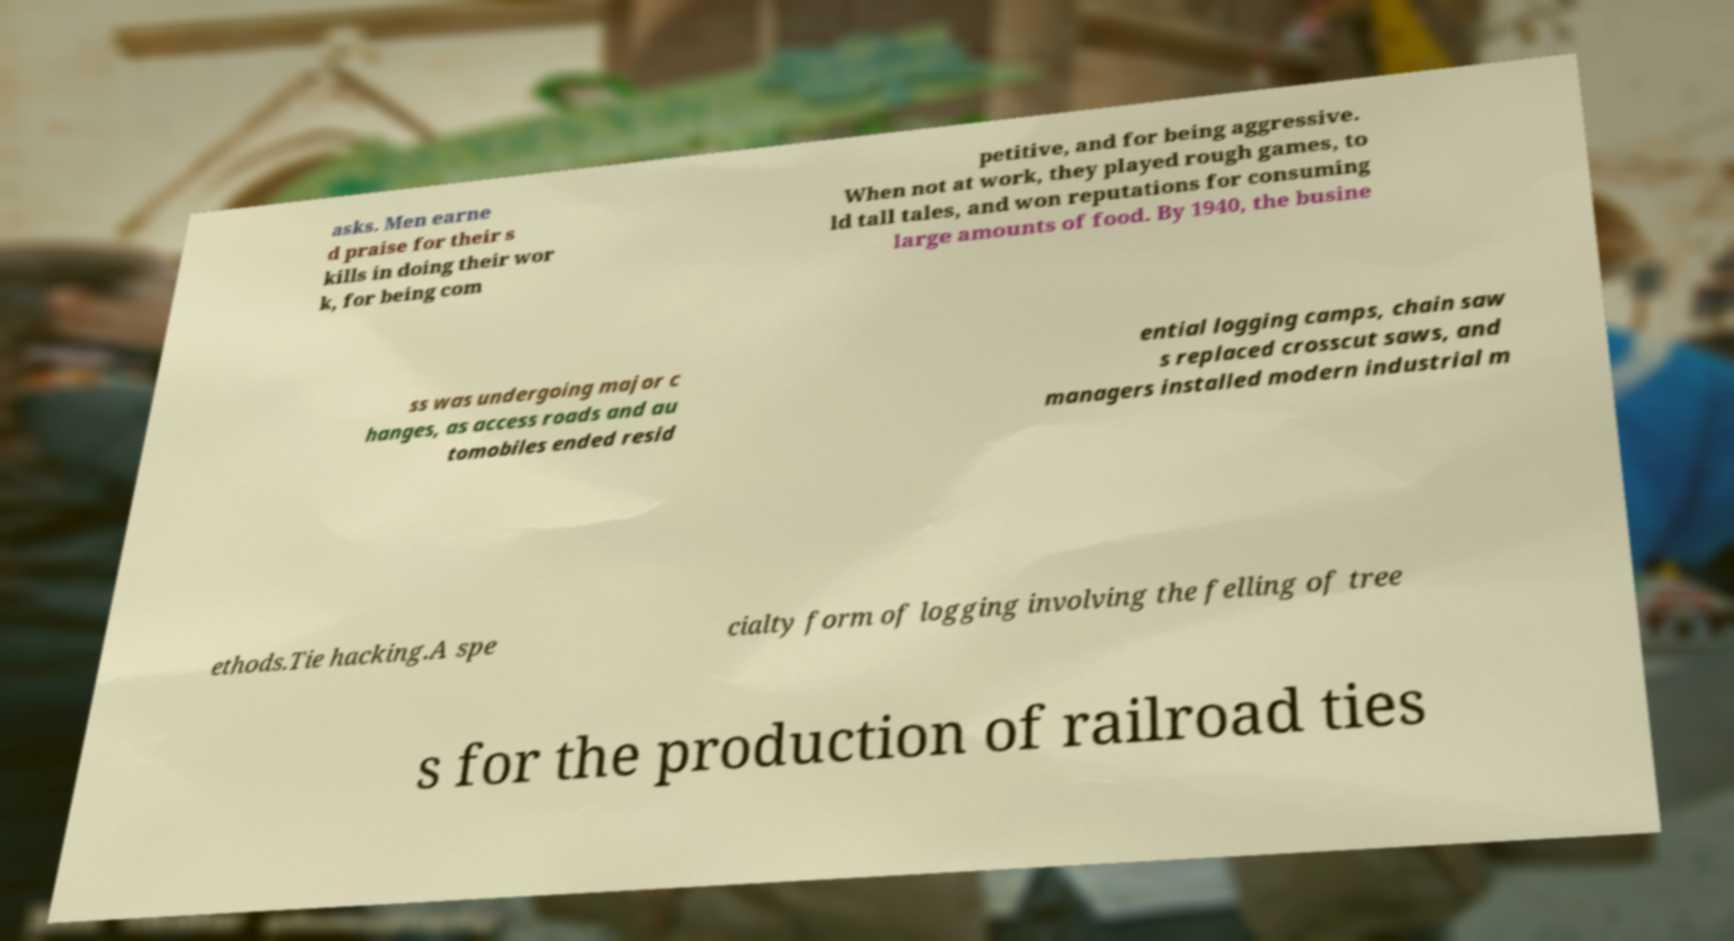Can you accurately transcribe the text from the provided image for me? asks. Men earne d praise for their s kills in doing their wor k, for being com petitive, and for being aggressive. When not at work, they played rough games, to ld tall tales, and won reputations for consuming large amounts of food. By 1940, the busine ss was undergoing major c hanges, as access roads and au tomobiles ended resid ential logging camps, chain saw s replaced crosscut saws, and managers installed modern industrial m ethods.Tie hacking.A spe cialty form of logging involving the felling of tree s for the production of railroad ties 